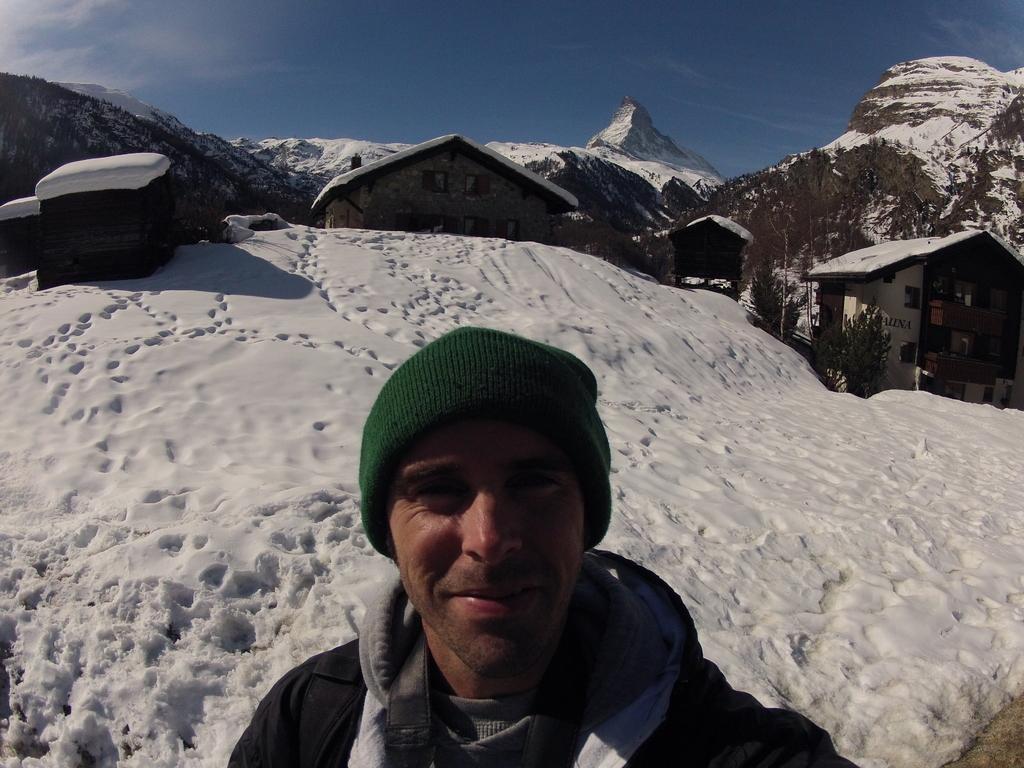In one or two sentences, can you explain what this image depicts? In this image we can see a man and there are some buildings and trees which are covered with the snow and in the background, we can see the mountains and at the top we can see the sky. 